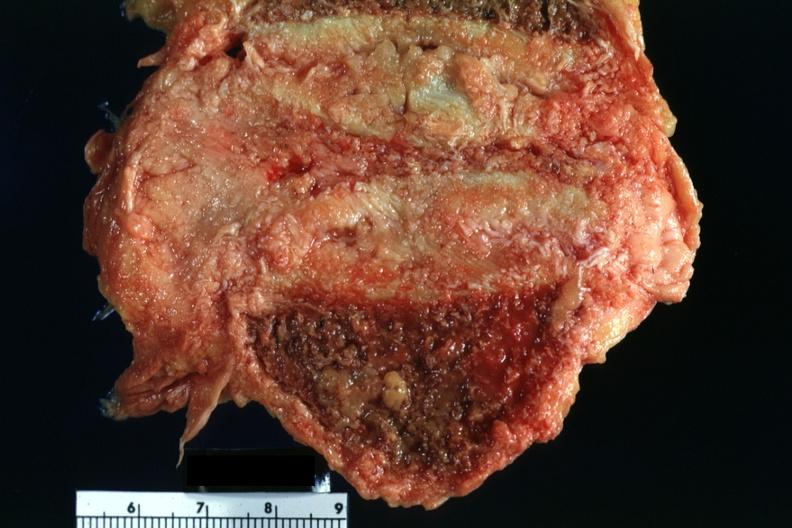what is present?
Answer the question using a single word or phrase. Joints 